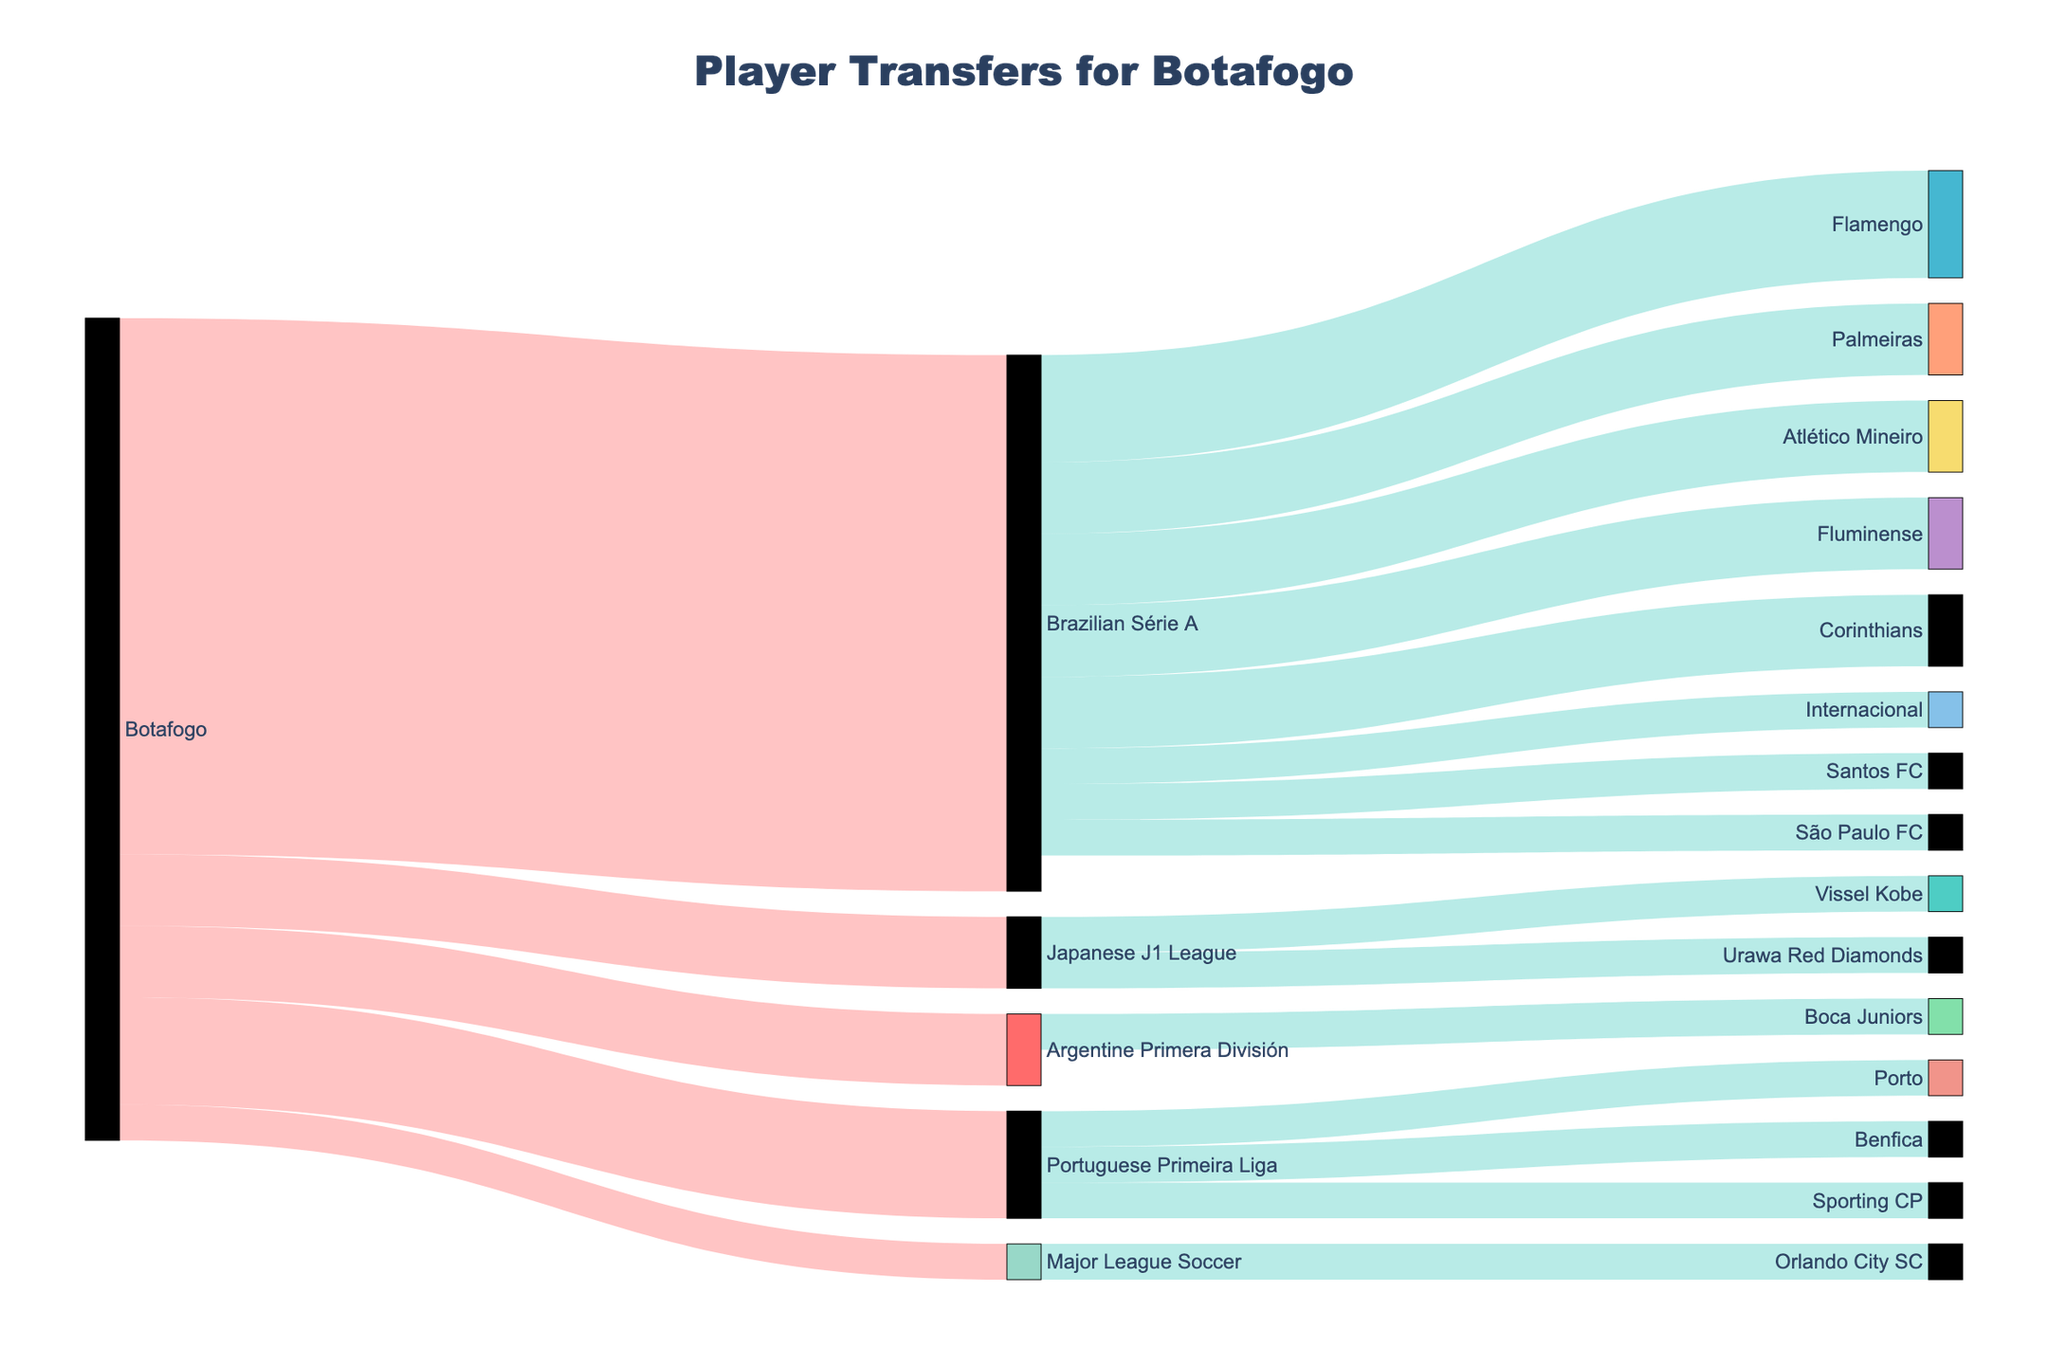What is the title of the Sankey diagram? The title of a diagram is usually found at the top, centered above the figure. Here it's "Player Transfers for Botafogo", which can be inferred by looking at the title set in the layout of the plot.
Answer: Player Transfers for Botafogo How many leagues has Botafogo transferred players to? By examining the connections extending from Botafogo, we observe transfers to Brazilian Série A, Portuguese Primeira Liga, Argentine Primera División, Major League Soccer, and Japanese J1 League. Counting these distinct leagues, we find there are five.
Answer: 5 Which league received the most players from Botafogo? Observing the connections from Botafogo, the largest value associated with a single target league is 15, which corresponds to Brazilian Série A. This indicates that Brazilian Série A received the most players.
Answer: Brazilian Série A How many players were transferred from Brazilian Série A to different teams? We look at the sum of values for all connections starting from Brazilian Série A and ending in different teams. These values are 2 (Fluminense), 3 (Flamengo), 1 (São Paulo FC), 2 (Palmeiras), 1 (Internacional), 2 (Atlético Mineiro), 1 (Santos FC), and 2 (Corinthians). Summing these, we get 14.
Answer: 14 List all the teams connected to the Portuguese Primeira Liga. To determine this, we look at all connections leading from Portuguese Primeira Liga. The teams involved are Benfica, Porto, and Sporting CP.
Answer: Benfica, Porto, Sporting CP Which team in the Major League Soccer received a player from Botafogo? We inspect the link from Botafogo to the Major League Soccer and trace the connection. Since it leads to Orlando City SC, we conclude that Orlando City SC is the team that received a player.
Answer: Orlando City SC How many total players were transferred by Botafogo to the Japanese J1 League? Observing the link values, we see Botafogo sent two players to the Japanese J1 League.
Answer: 2 What is the unique team in the Argentine Primera División that received players from Botafogo? Examining the connections from the Argentine Primera División, we find a single link leading to Boca Juniors.
Answer: Boca Juniors Compare the number of players Botafogo transferred to the Portuguese Primeira Liga versus the Japanese J1 League. Botafogo transferred three players to the Portuguese Primeira Liga and two players to the Japanese J1 League. By comparing these numbers, we find that more players were sent to the Portuguese Primeira Liga.
Answer: Portuguese Primeira Liga What is the total number of different teams involved in player transfers within the diagram? By enumerating the unique team names listed under the target column (Fluminense, Flamengo, São Paulo FC, Palmeiras, Internacional, Atlético Mineiro, Santos FC, Corinthians, Benfica, Porto, Boca Juniors, Orlando City SC, Vissel Kobe, Urawa Red Diamonds, Sporting CP), we identify fifteen distinct teams.
Answer: 15 